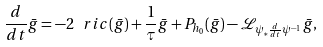<formula> <loc_0><loc_0><loc_500><loc_500>\frac { d } { d t } \bar { g } = - 2 \ r i c ( \bar { g } ) + \frac { 1 } { \tau } \bar { g } + P _ { h _ { 0 } } ( \bar { g } ) - \mathcal { L } _ { \psi _ { * } \frac { d } { d t } \psi ^ { - 1 } } \bar { g } ,</formula> 